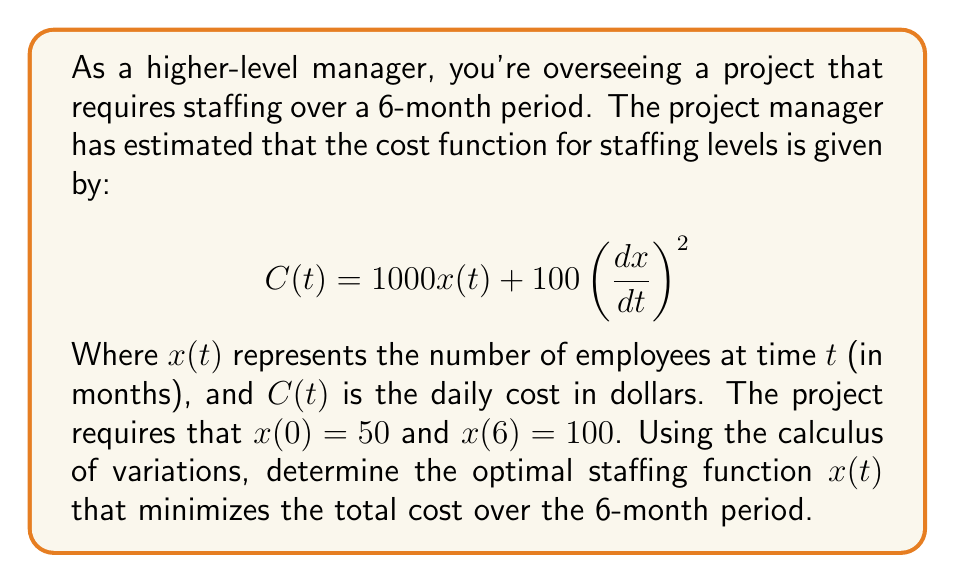What is the answer to this math problem? To solve this problem, we'll use the Euler-Lagrange equation from the calculus of variations. The steps are as follows:

1) The functional to be minimized is:

   $$J[x] = \int_0^6 \left(1000x(t) + 100\left(\frac{dx}{dt}\right)^2\right) dt$$

2) The Euler-Lagrange equation is:

   $$\frac{\partial F}{\partial x} - \frac{d}{dt}\left(\frac{\partial F}{\partial x'}\right) = 0$$

   where $F = 1000x(t) + 100\left(\frac{dx}{dt}\right)^2$

3) Calculating the partial derivatives:

   $$\frac{\partial F}{\partial x} = 1000$$
   $$\frac{\partial F}{\partial x'} = 200\frac{dx}{dt}$$

4) Substituting into the Euler-Lagrange equation:

   $$1000 - \frac{d}{dt}\left(200\frac{dx}{dt}\right) = 0$$

5) Simplifying:

   $$1000 - 200\frac{d^2x}{dt^2} = 0$$
   $$\frac{d^2x}{dt^2} = 5$$

6) Integrating twice:

   $$\frac{dx}{dt} = 5t + C_1$$
   $$x(t) = \frac{5}{2}t^2 + C_1t + C_2$$

7) Using the boundary conditions to solve for $C_1$ and $C_2$:

   $x(0) = 50$ implies $C_2 = 50$
   $x(6) = 100$ implies $90 + 6C_1 + 50 = 100$
   Solving: $C_1 = -\frac{40}{6} = -\frac{20}{3}$

8) Therefore, the optimal staffing function is:

   $$x(t) = \frac{5}{2}t^2 - \frac{20}{3}t + 50$$

This function represents the optimal number of employees at any given time $t$ during the 6-month project period.
Answer: The optimal staffing function that minimizes the total cost over the 6-month period is:

$$x(t) = \frac{5}{2}t^2 - \frac{20}{3}t + 50$$

where $t$ is measured in months from 0 to 6. 